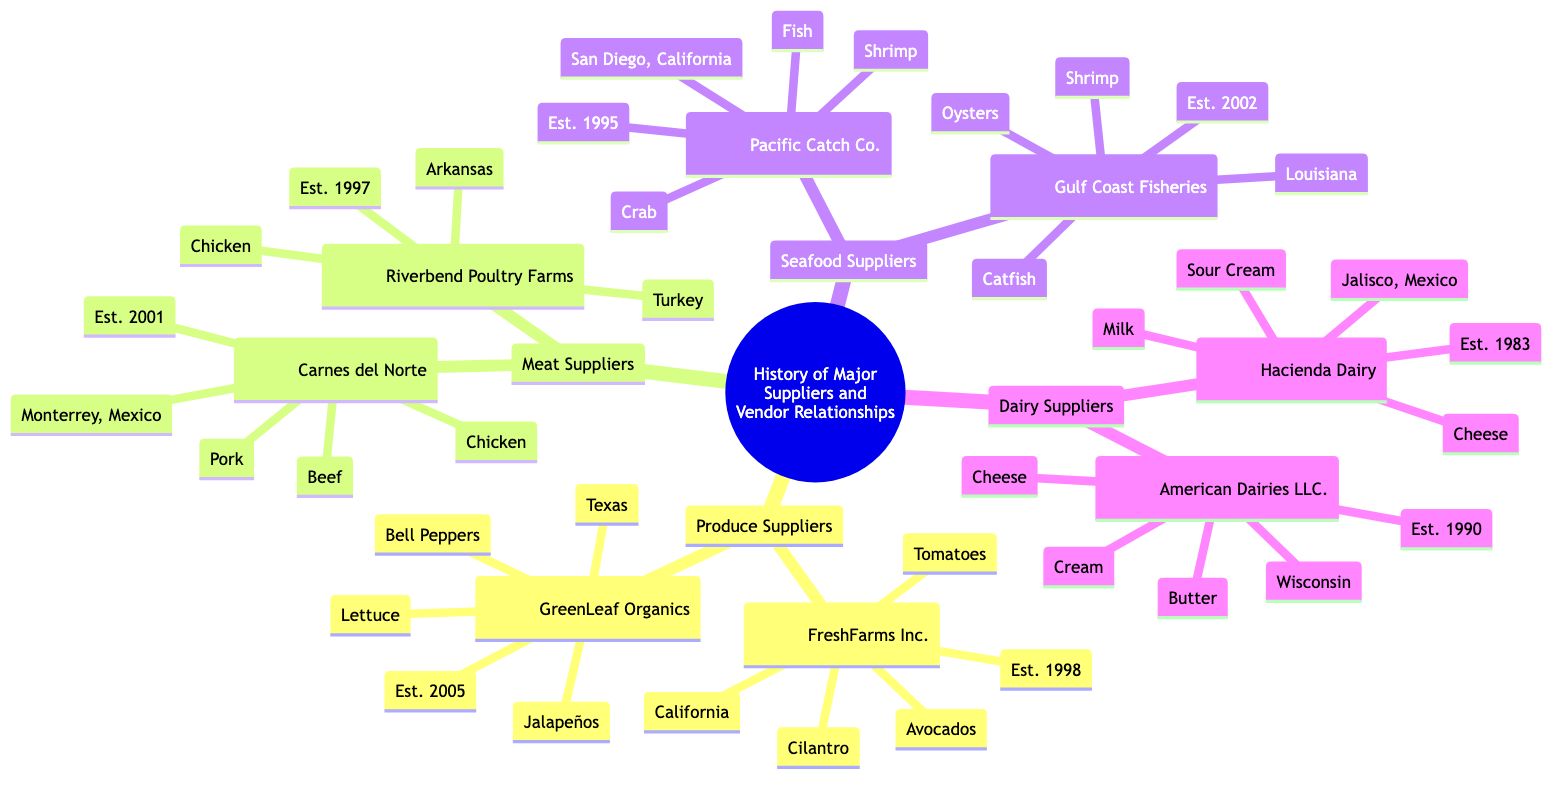What are the key products of FreshFarms Inc.? According to the diagram, FreshFarms Inc. lists its key products as Tomatoes, Cilantro, and Avocados.
Answer: Tomatoes, Cilantro, Avocados In which year was Riverbend Poultry Farms established? The diagram states that Riverbend Poultry Farms was established in 1997.
Answer: 1997 How many produce suppliers are listed? The diagram shows two produce suppliers: FreshFarms Inc. and GreenLeaf Organics.
Answer: 2 Which meat supplier is located in Monterrey, Mexico? The diagram indicates that Carnes del Norte is the meat supplier located in Monterrey, Mexico.
Answer: Carnes del Norte What are the three key products of Gulf Coast Fisheries? The diagram specifies that Gulf Coast Fisheries has Shrimp, Oysters, and Catfish as its key products.
Answer: Shrimp, Oysters, Catfish Which type of supplier has the earliest establishment date? By analyzing the diagram, Hacienda Dairy, established in 1983, is the earliest supplier listed.
Answer: Hacienda Dairy What is the location of GreenLeaf Organics? The diagram provides the location of GreenLeaf Organics as Texas.
Answer: Texas Which supplier focuses on dairy products? The diagram shows that both Hacienda Dairy and American Dairies LLC. are focused on dairy products.
Answer: Hacienda Dairy and American Dairies LLC How many total seafood suppliers are there? From the diagram, it is clear that there are two seafood suppliers: Pacific Catch Co. and Gulf Coast Fisheries.
Answer: 2 